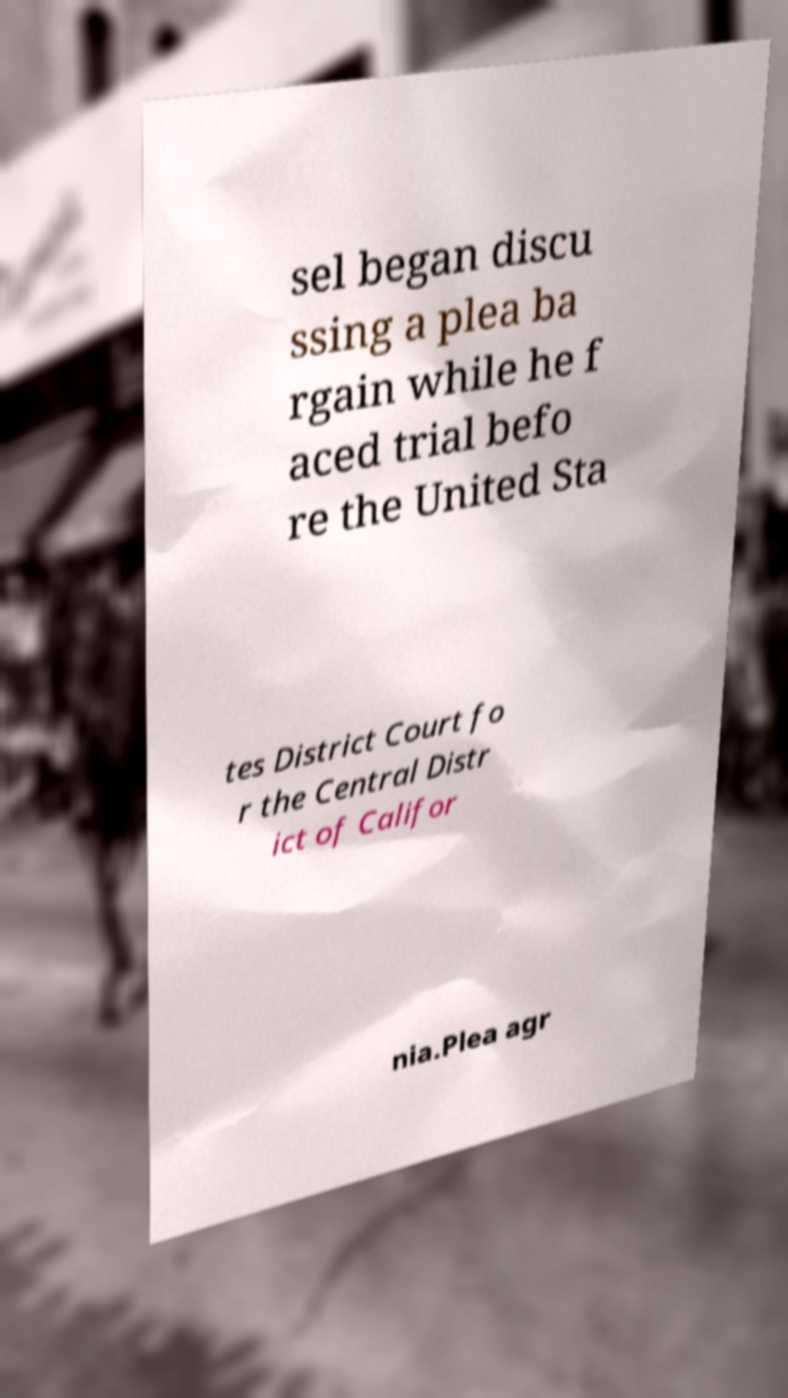Could you assist in decoding the text presented in this image and type it out clearly? sel began discu ssing a plea ba rgain while he f aced trial befo re the United Sta tes District Court fo r the Central Distr ict of Califor nia.Plea agr 